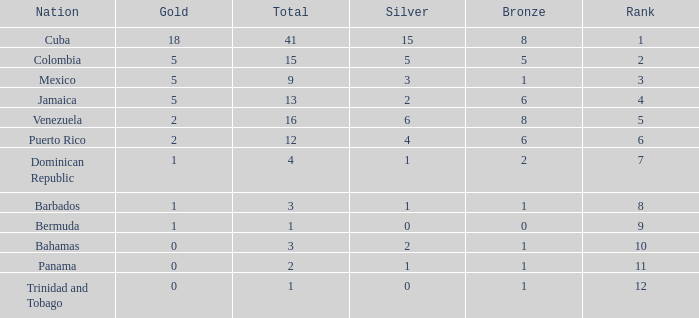Which Bronze is the highest one that has a Rank larger than 1, and a Nation of dominican republic, and a Total larger than 4? None. 